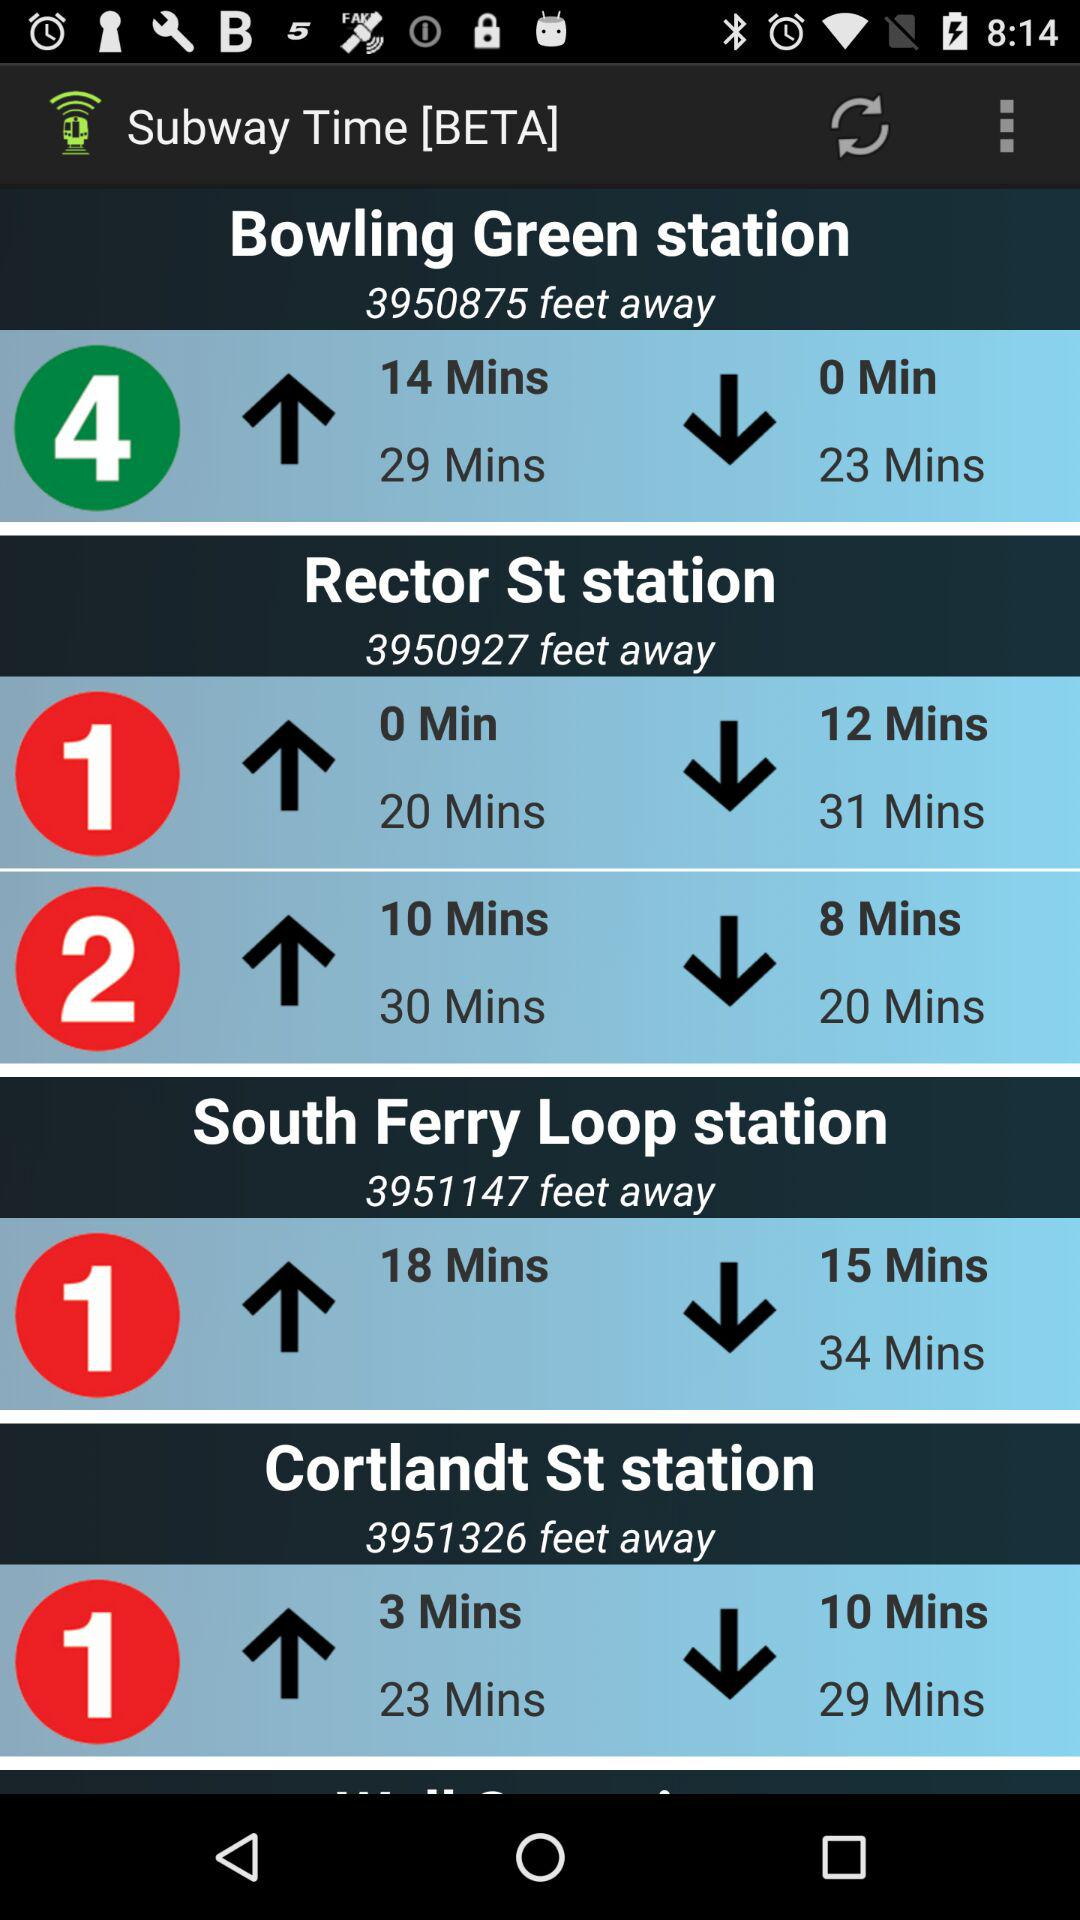Which station is further away, Rector St or Cortlandt St?
Answer the question using a single word or phrase. Cortlandt St 